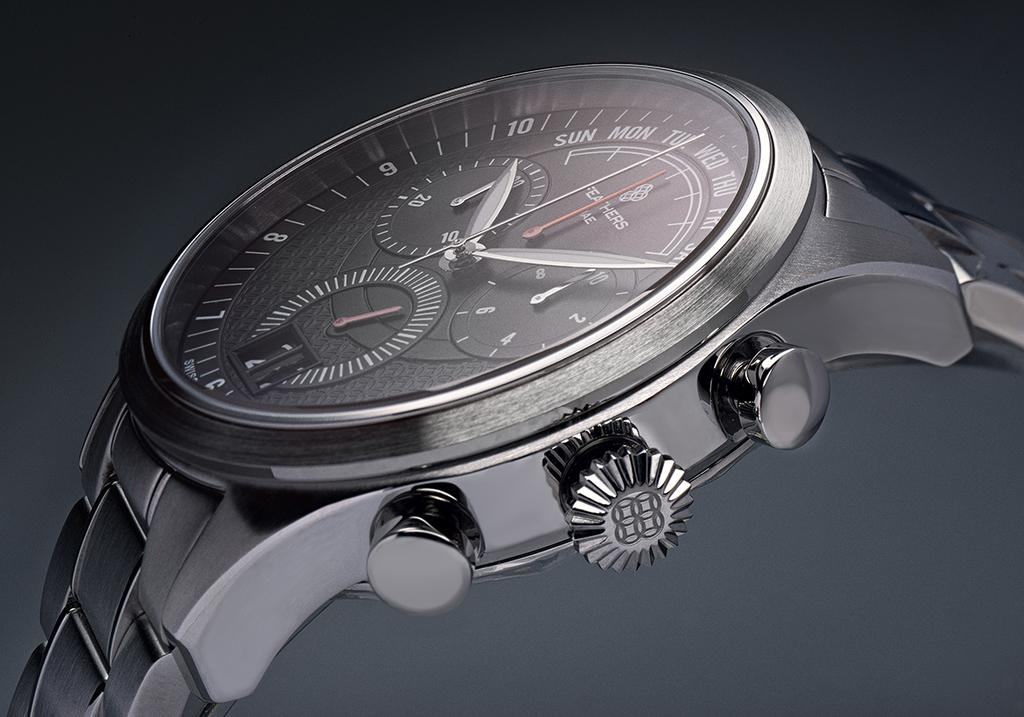<image>
Write a terse but informative summary of the picture. Face of a watch which says FEATHERS on it in white. 